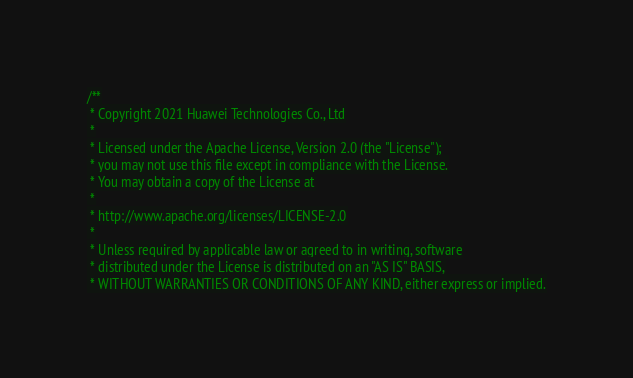Convert code to text. <code><loc_0><loc_0><loc_500><loc_500><_Cuda_>/**
 * Copyright 2021 Huawei Technologies Co., Ltd
 *
 * Licensed under the Apache License, Version 2.0 (the "License");
 * you may not use this file except in compliance with the License.
 * You may obtain a copy of the License at
 *
 * http://www.apache.org/licenses/LICENSE-2.0
 *
 * Unless required by applicable law or agreed to in writing, software
 * distributed under the License is distributed on an "AS IS" BASIS,
 * WITHOUT WARRANTIES OR CONDITIONS OF ANY KIND, either express or implied.</code> 